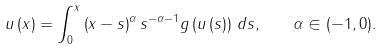<formula> <loc_0><loc_0><loc_500><loc_500>u \left ( x \right ) = \int _ { 0 } ^ { x } \left ( x - s \right ) ^ { \alpha } s ^ { - \alpha - 1 } g \left ( u \left ( s \right ) \right ) \, d s , \quad \alpha \in ( - 1 , 0 ) .</formula> 